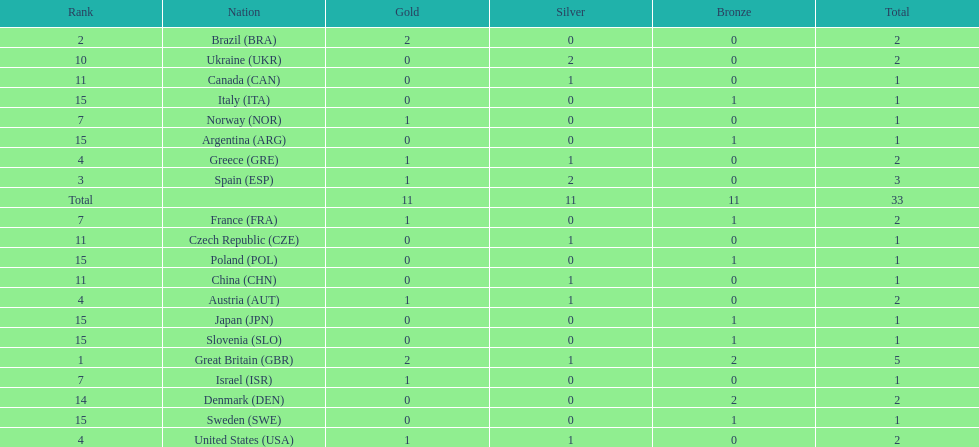Who won more gold medals than spain? Great Britain (GBR), Brazil (BRA). 